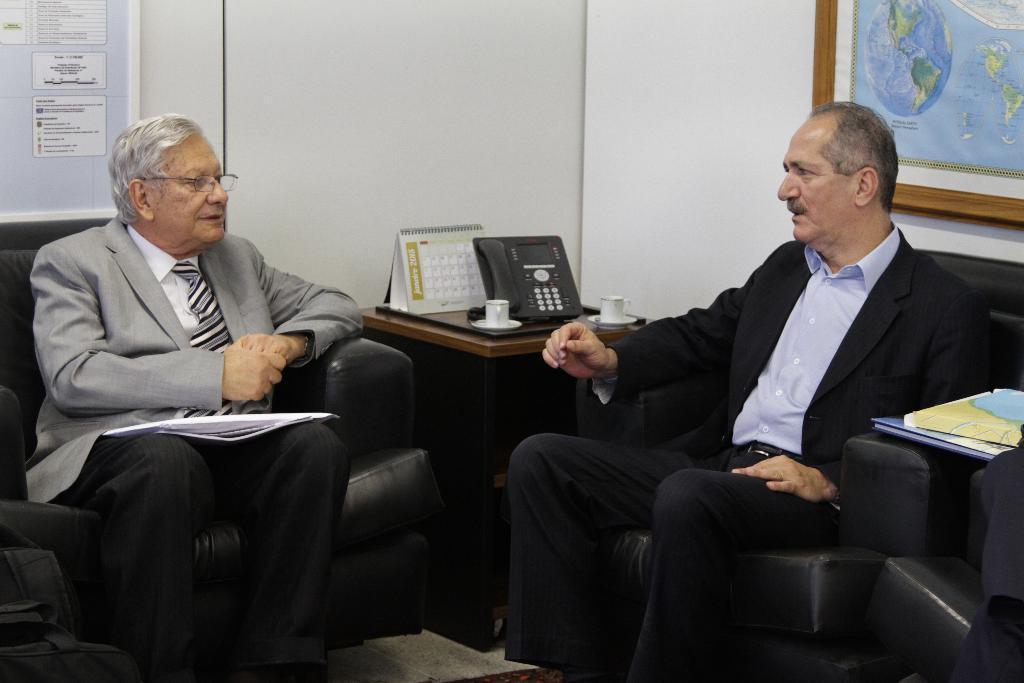Describe this image in one or two sentences. In this image we can see two men sitting on the sofa. They are wearing a suit and a tie. They are having a conversation. Here we can see the wooden table. Here we can see a telephone, a calendar and two cups are kept on the table. Here we can see the files on the right side. Here we can see the world map on the wall and it is on the top right side. 